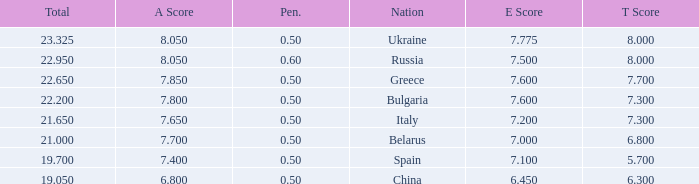What E score has the T score of 8 and a number smaller than 22.95? None. 